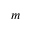<formula> <loc_0><loc_0><loc_500><loc_500>m</formula> 